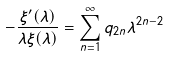Convert formula to latex. <formula><loc_0><loc_0><loc_500><loc_500>- \frac { \xi ^ { \prime } ( \lambda ) } { \lambda \xi ( \lambda ) } = \sum _ { n = 1 } ^ { \infty } q _ { 2 n } \lambda ^ { 2 n - 2 }</formula> 